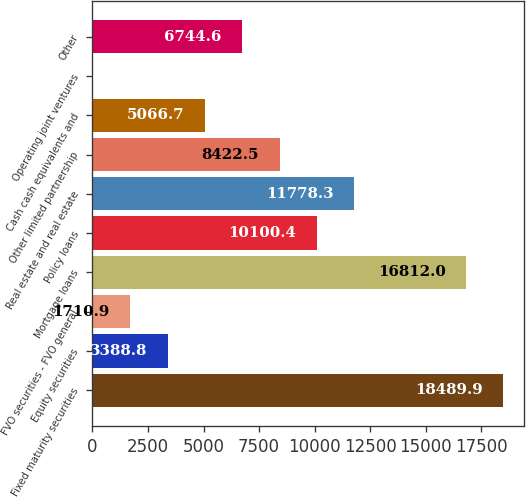<chart> <loc_0><loc_0><loc_500><loc_500><bar_chart><fcel>Fixed maturity securities<fcel>Equity securities<fcel>FVO securities - FVO general<fcel>Mortgage loans<fcel>Policy loans<fcel>Real estate and real estate<fcel>Other limited partnership<fcel>Cash cash equivalents and<fcel>Operating joint ventures<fcel>Other<nl><fcel>18489.9<fcel>3388.8<fcel>1710.9<fcel>16812<fcel>10100.4<fcel>11778.3<fcel>8422.5<fcel>5066.7<fcel>33<fcel>6744.6<nl></chart> 